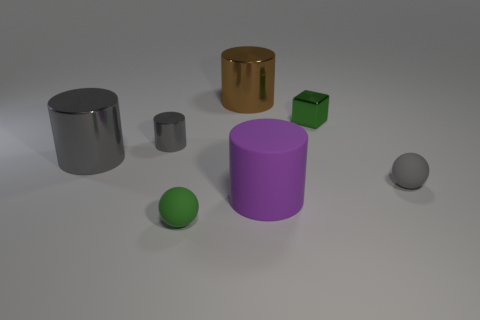There is a thing that is the same color as the tiny metallic block; what is its size?
Your answer should be very brief. Small. There is a brown cylinder; what number of small blocks are behind it?
Offer a terse response. 0. What is the small gray sphere made of?
Offer a very short reply. Rubber. Is the big matte object the same color as the tiny cube?
Ensure brevity in your answer.  No. Is the number of tiny green things right of the brown metal cylinder less than the number of small blue matte cubes?
Provide a short and direct response. No. There is a small rubber object behind the big purple object; what color is it?
Provide a short and direct response. Gray. What is the shape of the brown object?
Provide a succinct answer. Cylinder. Are there any big gray cylinders that are right of the large thing in front of the tiny rubber thing on the right side of the tiny green rubber sphere?
Your answer should be compact. No. There is a tiny matte sphere that is behind the cylinder on the right side of the thing behind the cube; what color is it?
Ensure brevity in your answer.  Gray. There is a small gray object that is the same shape as the large matte object; what is it made of?
Your answer should be very brief. Metal. 